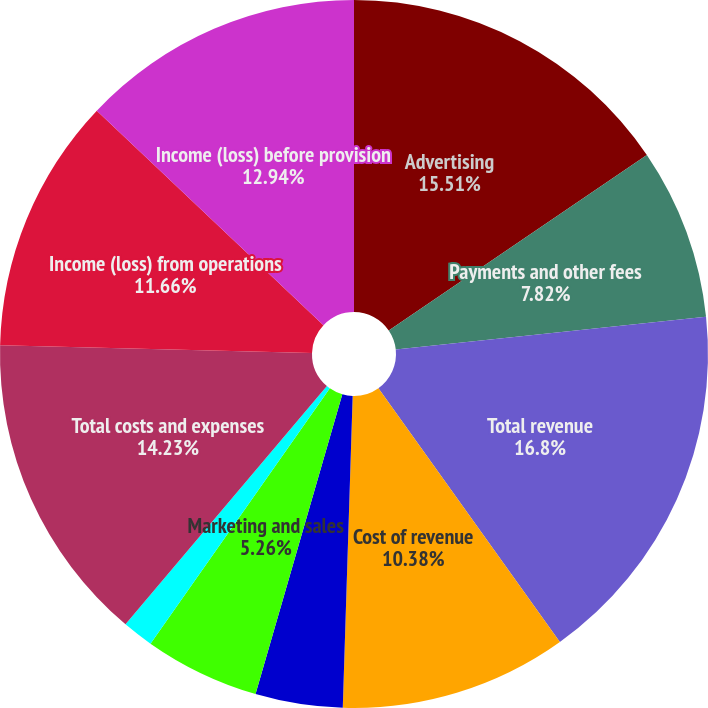Convert chart to OTSL. <chart><loc_0><loc_0><loc_500><loc_500><pie_chart><fcel>Advertising<fcel>Payments and other fees<fcel>Total revenue<fcel>Cost of revenue<fcel>Research and development<fcel>Marketing and sales<fcel>General and administrative<fcel>Total costs and expenses<fcel>Income (loss) from operations<fcel>Income (loss) before provision<nl><fcel>15.5%<fcel>7.82%<fcel>16.79%<fcel>10.38%<fcel>3.98%<fcel>5.26%<fcel>1.42%<fcel>14.22%<fcel>11.66%<fcel>12.94%<nl></chart> 